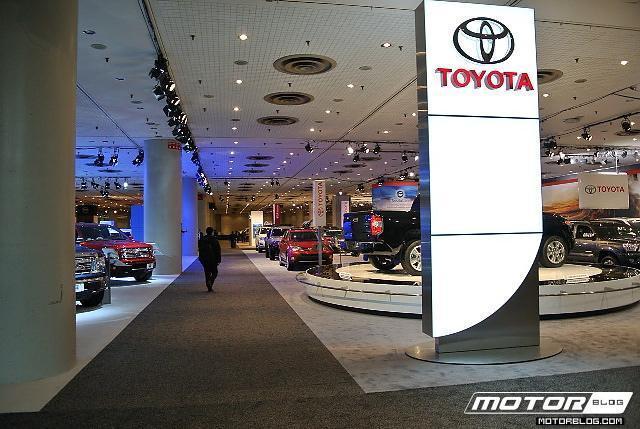How many people are in this photo?
Give a very brief answer. 1. How many cars are in the photo?
Give a very brief answer. 2. How many trucks can be seen?
Give a very brief answer. 3. 